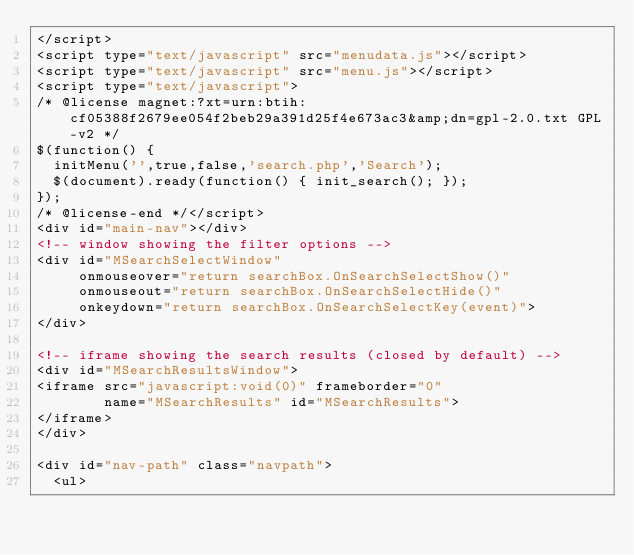Convert code to text. <code><loc_0><loc_0><loc_500><loc_500><_HTML_></script>
<script type="text/javascript" src="menudata.js"></script>
<script type="text/javascript" src="menu.js"></script>
<script type="text/javascript">
/* @license magnet:?xt=urn:btih:cf05388f2679ee054f2beb29a391d25f4e673ac3&amp;dn=gpl-2.0.txt GPL-v2 */
$(function() {
  initMenu('',true,false,'search.php','Search');
  $(document).ready(function() { init_search(); });
});
/* @license-end */</script>
<div id="main-nav"></div>
<!-- window showing the filter options -->
<div id="MSearchSelectWindow"
     onmouseover="return searchBox.OnSearchSelectShow()"
     onmouseout="return searchBox.OnSearchSelectHide()"
     onkeydown="return searchBox.OnSearchSelectKey(event)">
</div>

<!-- iframe showing the search results (closed by default) -->
<div id="MSearchResultsWindow">
<iframe src="javascript:void(0)" frameborder="0" 
        name="MSearchResults" id="MSearchResults">
</iframe>
</div>

<div id="nav-path" class="navpath">
  <ul></code> 